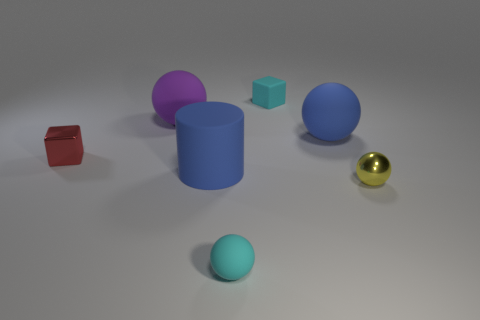Can you describe the lighting in the scene? The scene is lit from above with what seems like a single, diffuse light source. The soft shadows cast by the objects suggest the light is neither too intense nor too close, producing a gentle illumination over the entire composition. 